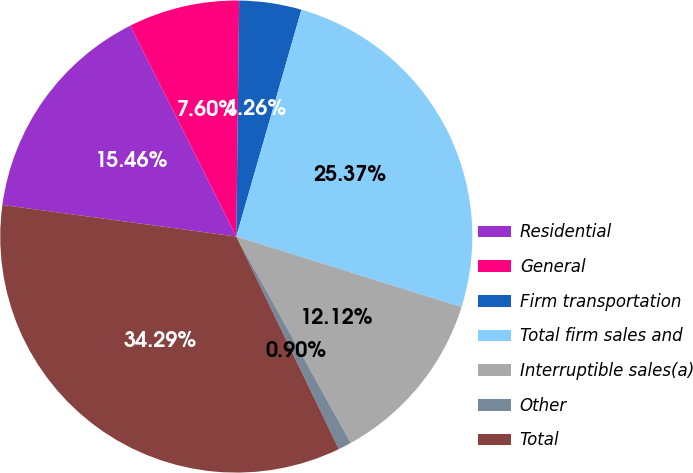Convert chart to OTSL. <chart><loc_0><loc_0><loc_500><loc_500><pie_chart><fcel>Residential<fcel>General<fcel>Firm transportation<fcel>Total firm sales and<fcel>Interruptible sales(a)<fcel>Other<fcel>Total<nl><fcel>15.46%<fcel>7.6%<fcel>4.26%<fcel>25.38%<fcel>12.12%<fcel>0.9%<fcel>34.3%<nl></chart> 